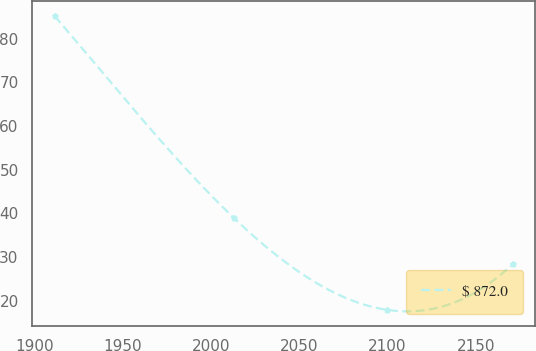<chart> <loc_0><loc_0><loc_500><loc_500><line_chart><ecel><fcel>$ 872.0<nl><fcel>1911.21<fcel>85.12<nl><fcel>2013.09<fcel>38.85<nl><fcel>2099.52<fcel>17.94<nl><fcel>2170.94<fcel>28.36<nl></chart> 